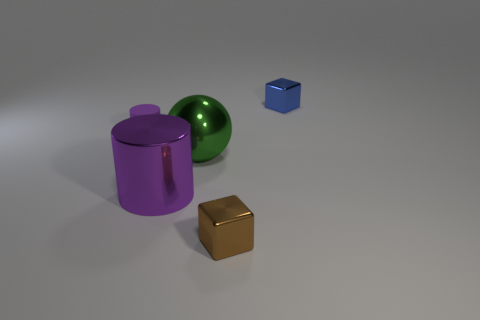What number of other things are there of the same material as the brown object
Your answer should be very brief. 3. There is a small blue metal thing; what number of tiny metallic blocks are behind it?
Offer a very short reply. 0. What number of balls are tiny brown metallic things or large purple objects?
Offer a terse response. 0. There is a object that is both left of the big green metal thing and behind the large purple shiny thing; what size is it?
Offer a very short reply. Small. What number of other things are the same color as the large sphere?
Provide a succinct answer. 0. Are the brown object and the object behind the small purple matte cylinder made of the same material?
Offer a terse response. Yes. What number of objects are large things that are behind the big purple thing or small rubber cylinders?
Provide a succinct answer. 2. What shape is the thing that is both left of the brown shiny object and behind the large shiny ball?
Provide a succinct answer. Cylinder. The sphere that is made of the same material as the brown block is what size?
Give a very brief answer. Large. How many objects are tiny metallic objects on the left side of the blue metallic block or tiny objects to the left of the big green object?
Your answer should be very brief. 2. 